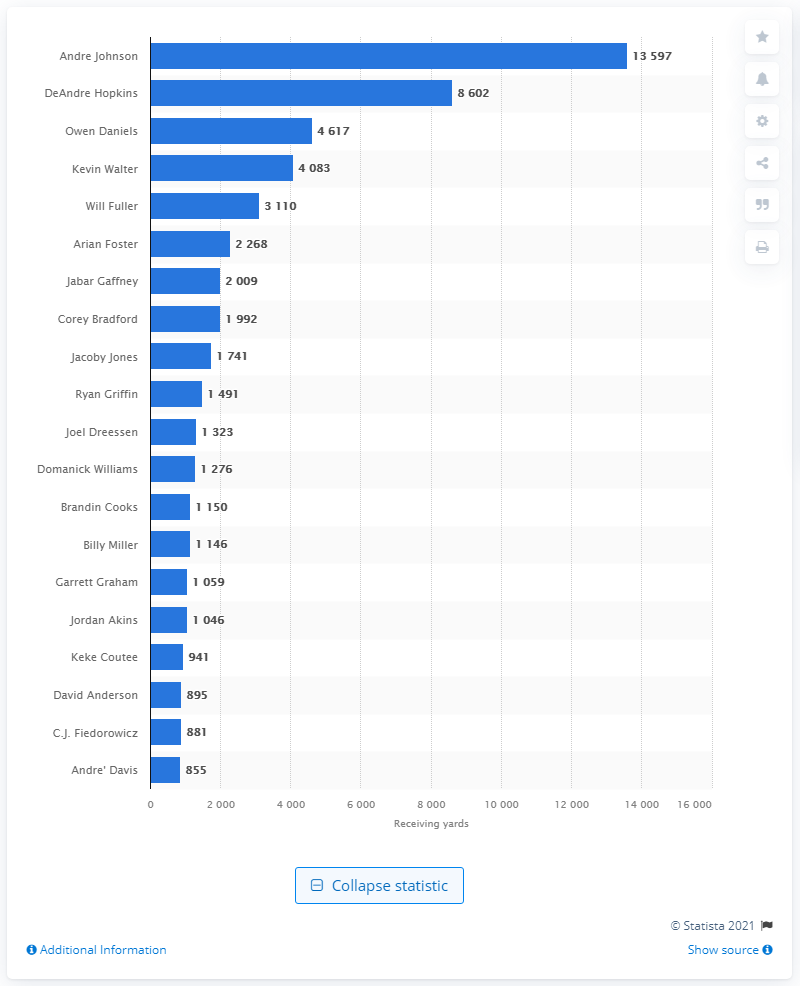Point out several critical features in this image. Andre Johnson is the career receiving leader of the Houston Texans. 